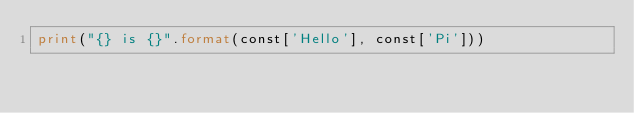Convert code to text. <code><loc_0><loc_0><loc_500><loc_500><_Python_>print("{} is {}".format(const['Hello'], const['Pi']))
</code> 